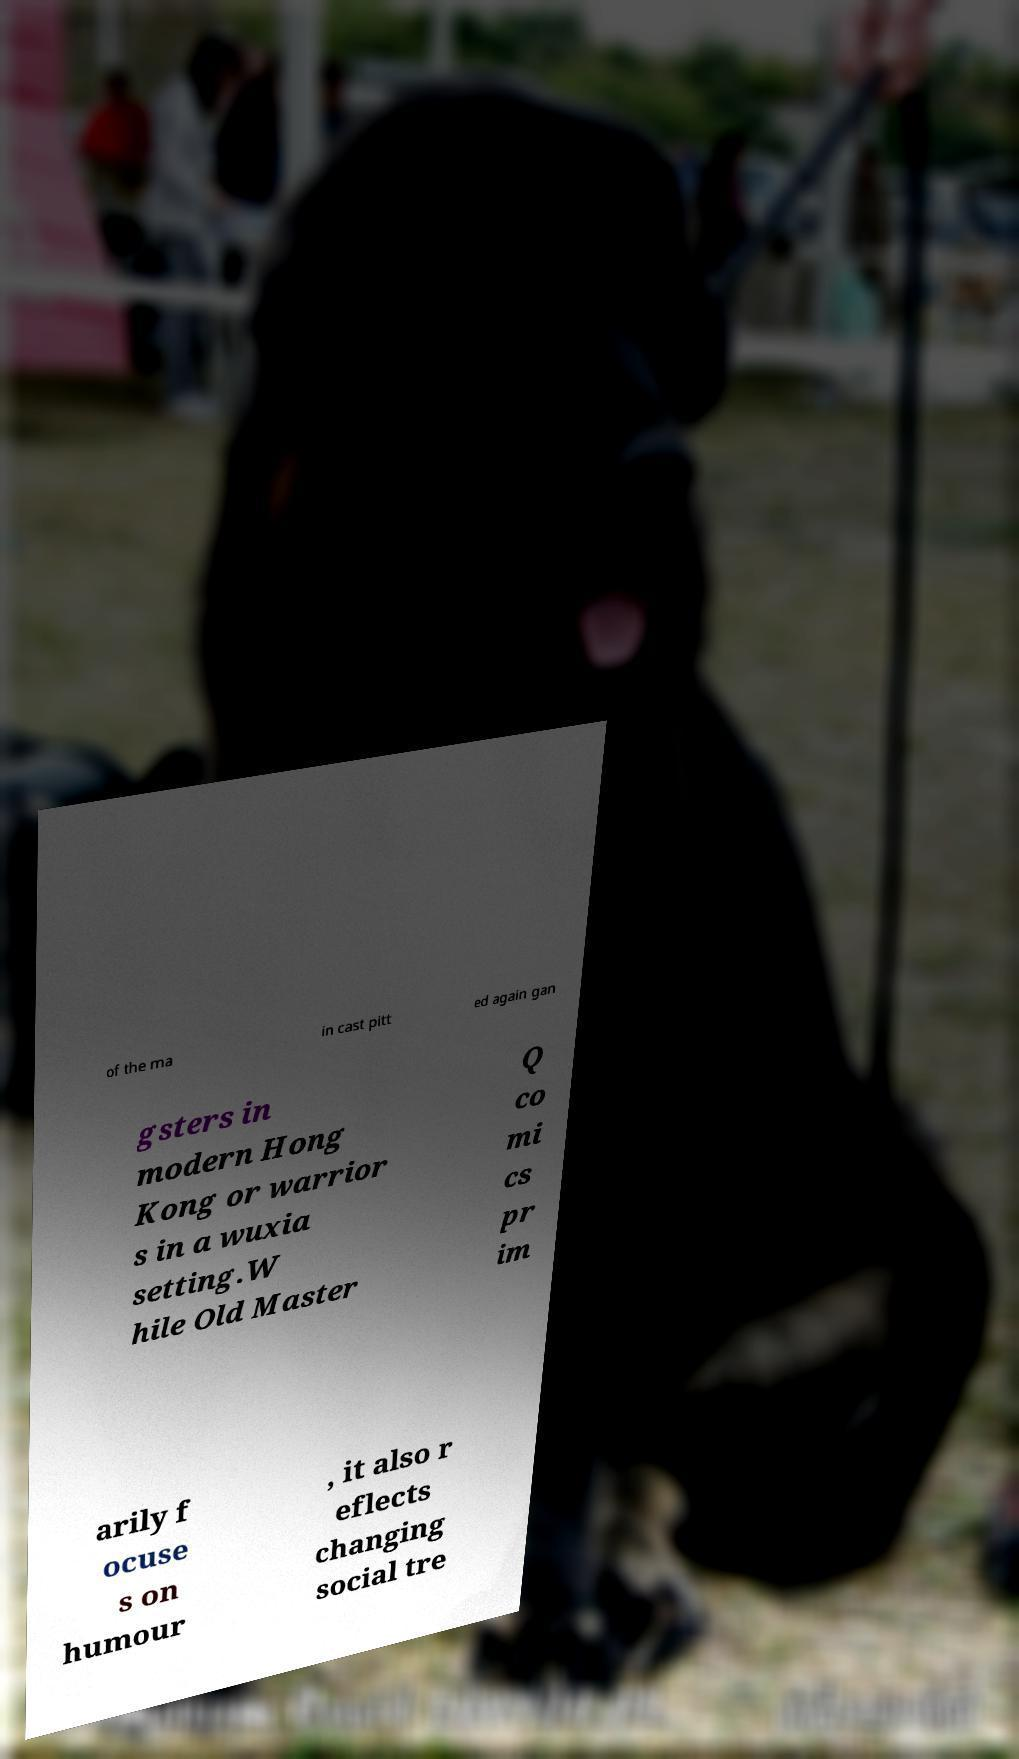Can you read and provide the text displayed in the image?This photo seems to have some interesting text. Can you extract and type it out for me? of the ma in cast pitt ed again gan gsters in modern Hong Kong or warrior s in a wuxia setting.W hile Old Master Q co mi cs pr im arily f ocuse s on humour , it also r eflects changing social tre 